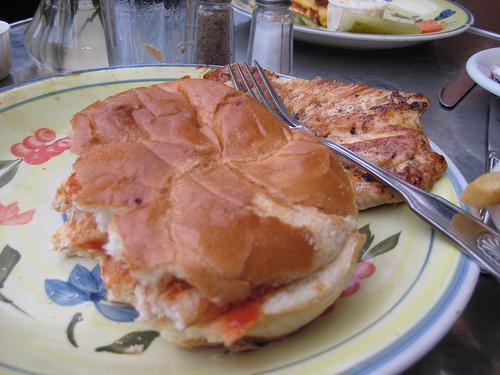How many utensils are on the plate?
Give a very brief answer. 1. How many tines are on the fork?
Give a very brief answer. 4. How many salt shakers are there?
Give a very brief answer. 1. 